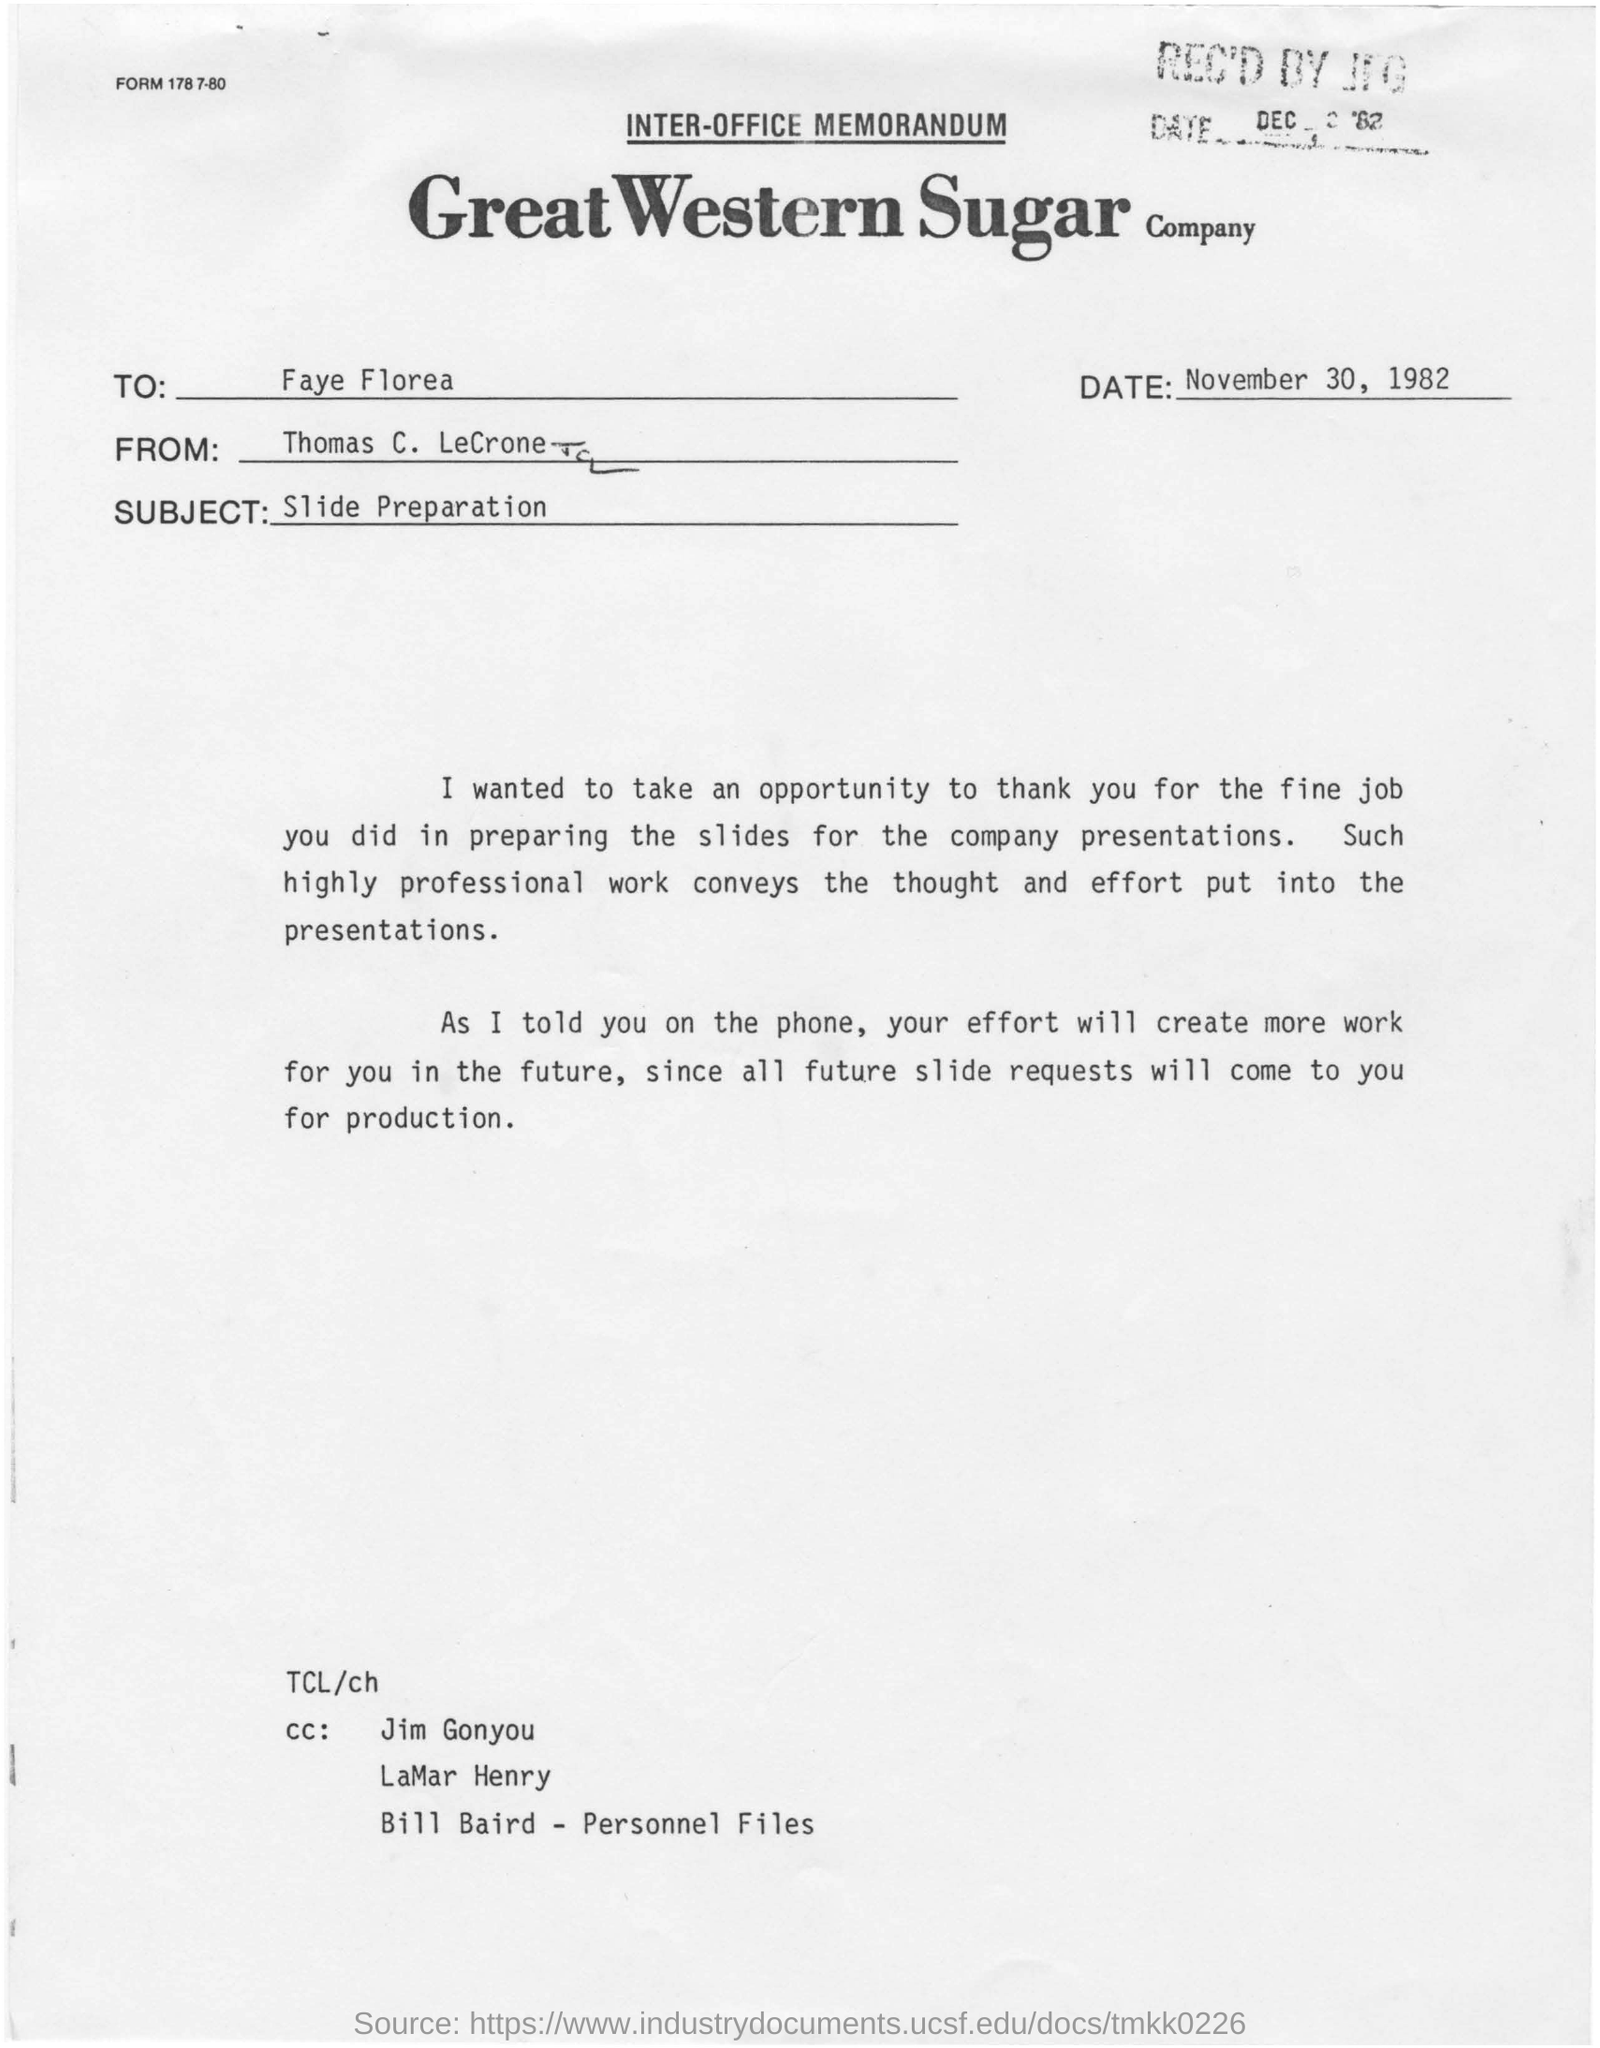To Whom is this memorandum addressed to?
Your answer should be compact. Faye Florea. From whom is the memorandum?
Your answer should be compact. Thomas C. LeCrone. When is the memorandum dated on?
Give a very brief answer. November 30, 1982. What is the subject of the memorandum?
Keep it short and to the point. Slide Preparation. 